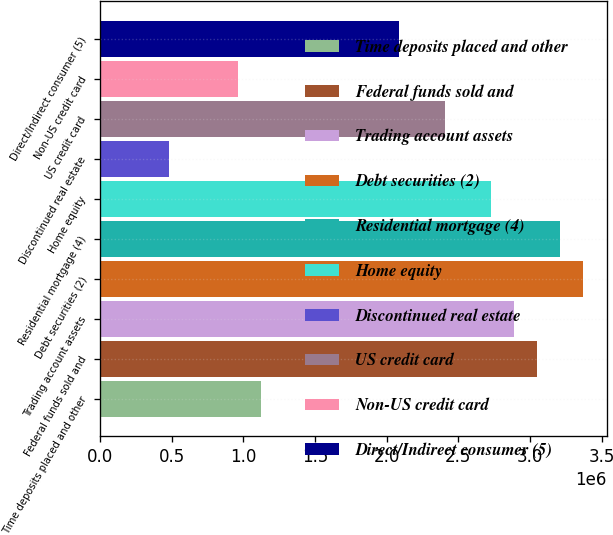Convert chart to OTSL. <chart><loc_0><loc_0><loc_500><loc_500><bar_chart><fcel>Time deposits placed and other<fcel>Federal funds sold and<fcel>Trading account assets<fcel>Debt securities (2)<fcel>Residential mortgage (4)<fcel>Home equity<fcel>Discontinued real estate<fcel>US credit card<fcel>Non-US credit card<fcel>Direct/Indirect consumer (5)<nl><fcel>1.12353e+06<fcel>3.04592e+06<fcel>2.88572e+06<fcel>3.36632e+06<fcel>3.20612e+06<fcel>2.72552e+06<fcel>482730<fcel>2.40512e+06<fcel>963328<fcel>2.08472e+06<nl></chart> 